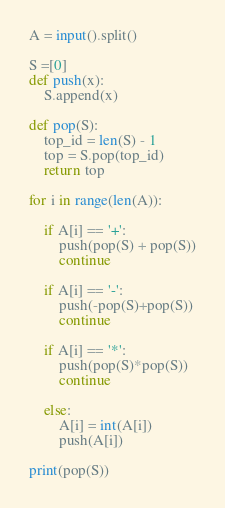Convert code to text. <code><loc_0><loc_0><loc_500><loc_500><_Python_>A = input().split()

S =[0]
def push(x):
    S.append(x)

def pop(S):
    top_id = len(S) - 1
    top = S.pop(top_id)
    return top

for i in range(len(A)):

    if A[i] == '+':
        push(pop(S) + pop(S))
        continue
    
    if A[i] == '-':
        push(-pop(S)+pop(S))
        continue
    
    if A[i] == '*':
        push(pop(S)*pop(S))
        continue
    
    else:
        A[i] = int(A[i])
        push(A[i])

print(pop(S))
</code> 